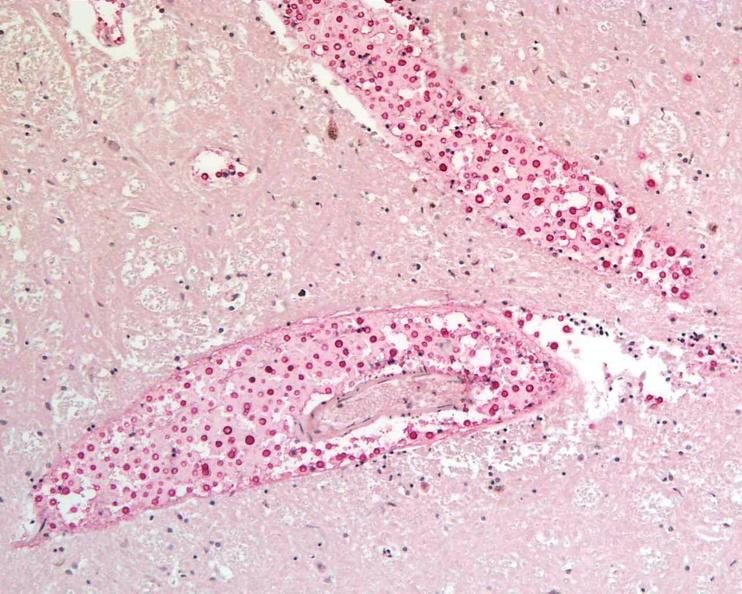does immunostain for growth hormone show brain, cryptococcal meningitis?
Answer the question using a single word or phrase. No 